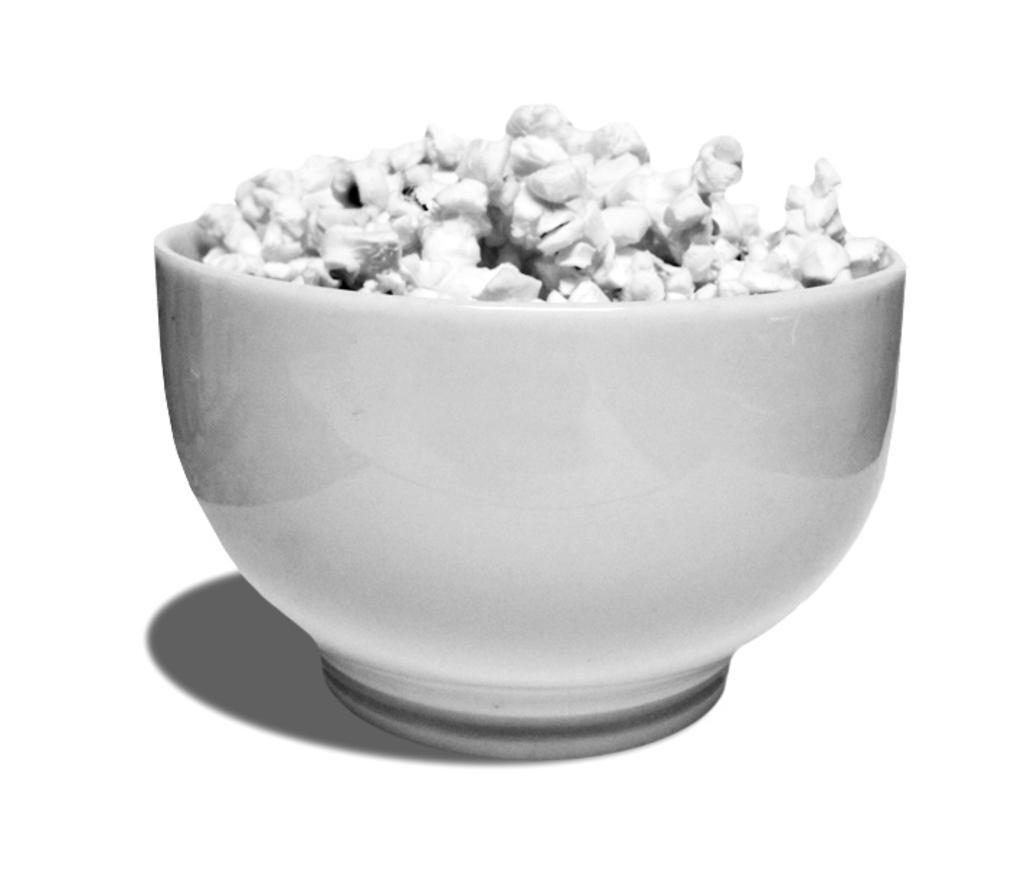How would you summarize this image in a sentence or two? In this image, we can see a white color bowl, there is some food kept in the bowl. 